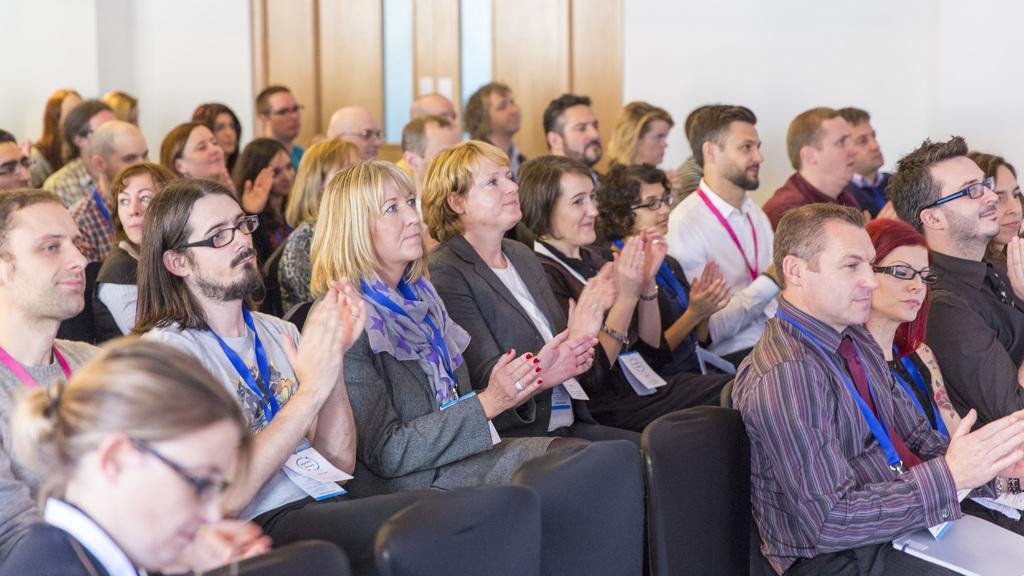How many people are present in the image? There are many people in the image. What are the people doing in the image? The people are sitting on chairs. What can be seen on the people's clothing? The people are wearing tags. Can you describe any accessories that some people are wearing? Some people are wearing glasses (specs). What is visible in the background of the image? There is a wall in the background of the image. What type of baseball error can be seen in the image? There is no baseball or error present in the image; it features people sitting on chairs and wearing tags. Can you tell me who is driving the car in the image? There is no car or driving present in the image. 